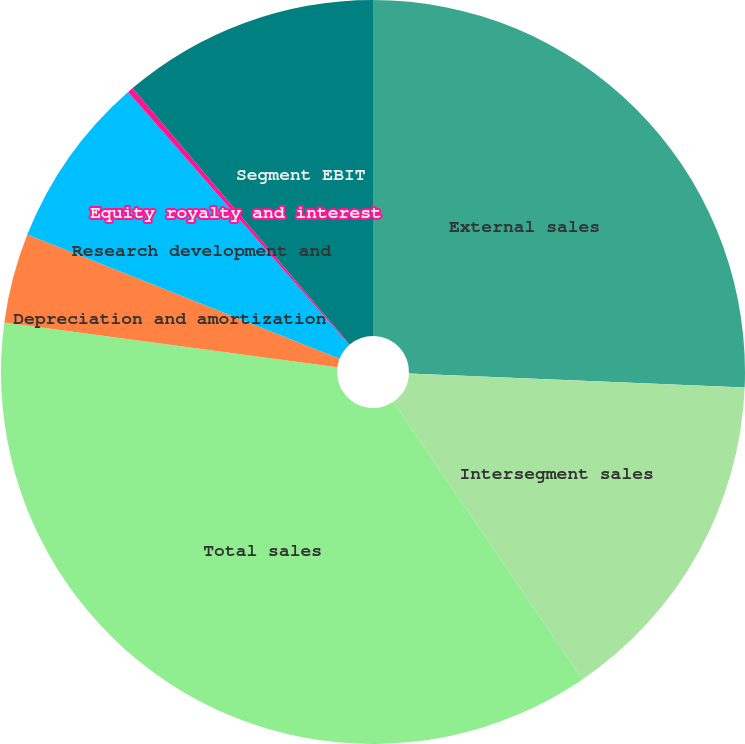Convert chart. <chart><loc_0><loc_0><loc_500><loc_500><pie_chart><fcel>External sales<fcel>Intersegment sales<fcel>Total sales<fcel>Depreciation and amortization<fcel>Research development and<fcel>Equity royalty and interest<fcel>Segment EBIT<nl><fcel>25.66%<fcel>14.82%<fcel>36.64%<fcel>3.9%<fcel>7.54%<fcel>0.26%<fcel>11.18%<nl></chart> 